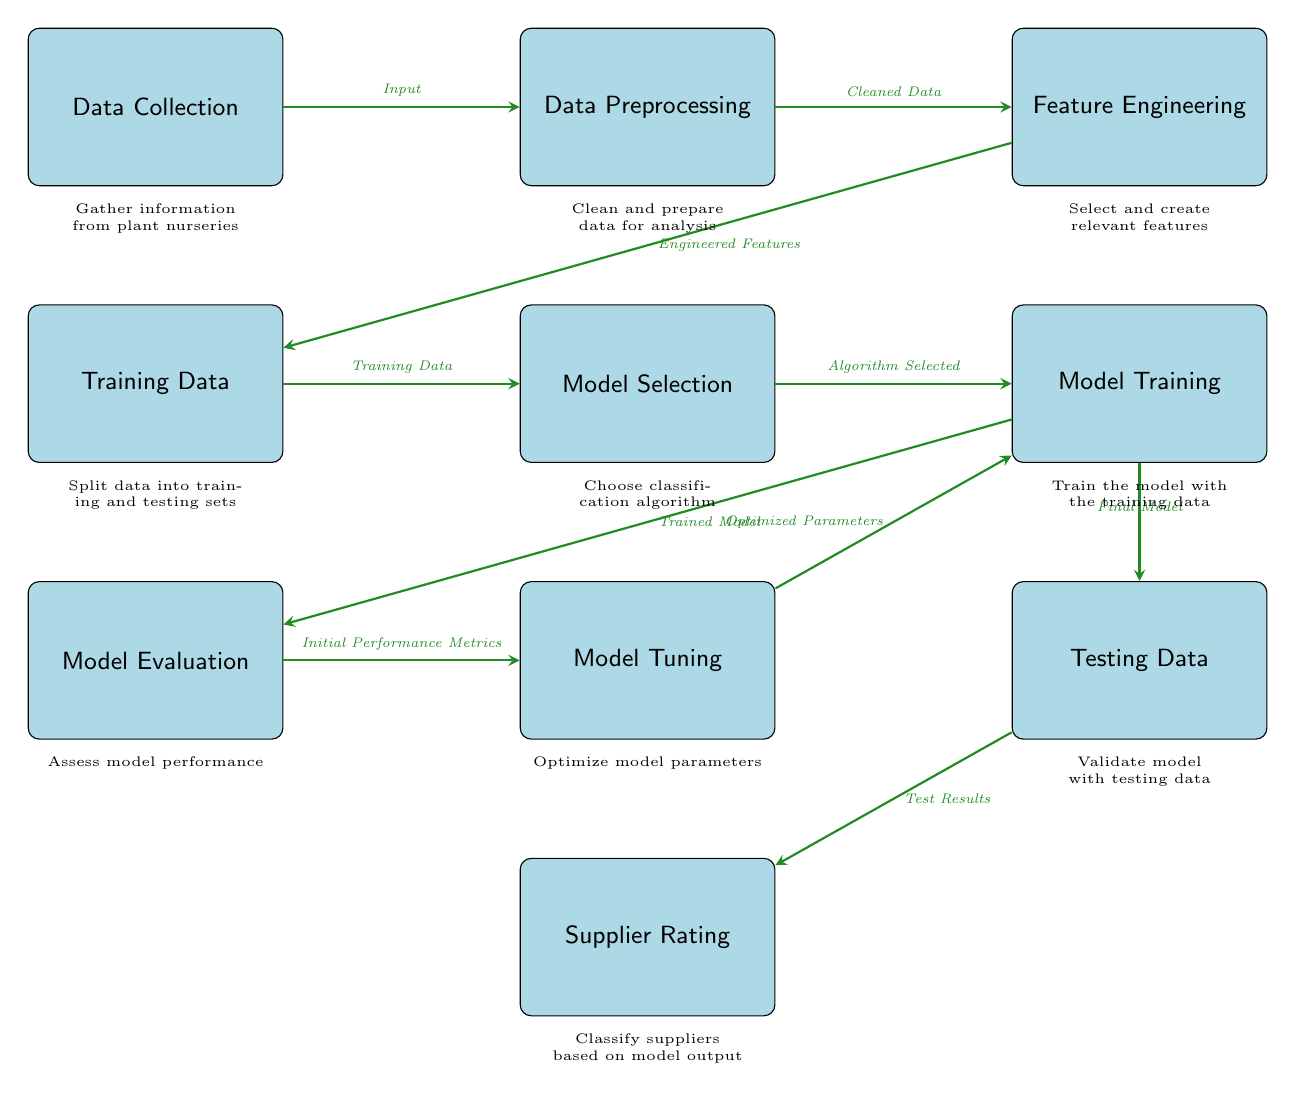What is the first step in the diagram? The first step in the diagram is labeled 'Data Collection', which is the starting point of the process.
Answer: Data Collection How many main process nodes are there in the diagram? The diagram has a total of 10 main process nodes connected in a flow, from 'Data Collection' to 'Supplier Rating'.
Answer: 10 What does the output of 'Model Evaluation' lead to? The output of the 'Model Evaluation' step leads to 'Model Tuning', indicating that performance metrics will prompt adjustments to the model parameters.
Answer: Model Tuning What is the role of 'Feature Engineering' in the process? 'Feature Engineering' is responsible for selecting and creating relevant features, which is an essential step that follows data preprocessing.
Answer: Select and create relevant features Which node comes after 'Model Training'? The node that follows 'Model Training' is 'Model Evaluation', showing the step to assess how well the model performs with the training data.
Answer: Model Evaluation What type of data is used in 'Training Data'? 'Training Data' refers to the data split specifically for training the model, taking input from the earlier stage.
Answer: Training Data What connects 'Model Tuning' to 'Model Training'? 'Model Tuning' connects to 'Model Training' through optimized parameters that are applied back to refine the model.
Answer: Optimized Parameters What is the end result of the entire process? The final result of the entire diagram process is 'Supplier Rating', which indicates the classification outcome based on model testing.
Answer: Supplier Rating What type of classification algorithms could be selected in 'Model Selection'? 'Model Selection' refers to choosing classification algorithms, but the specific algorithms are not mentioned; it typically involves decision trees, logistic regression, etc.
Answer: Algorithm Selected 